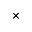<formula> <loc_0><loc_0><loc_500><loc_500>\times</formula> 